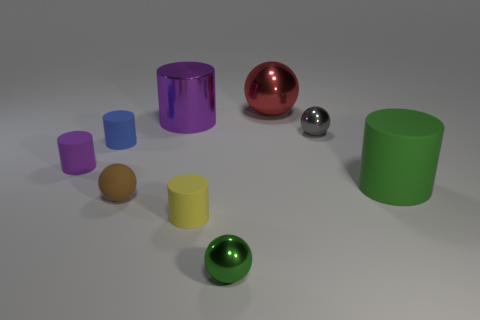Subtract all small matte spheres. How many spheres are left? 3 Subtract all blue cylinders. How many cylinders are left? 4 Add 1 small brown metallic things. How many objects exist? 10 Subtract all cyan spheres. Subtract all cyan cylinders. How many spheres are left? 4 Subtract all spheres. How many objects are left? 5 Add 7 yellow cylinders. How many yellow cylinders exist? 8 Subtract 1 blue cylinders. How many objects are left? 8 Subtract all large red matte blocks. Subtract all tiny brown things. How many objects are left? 8 Add 7 big matte objects. How many big matte objects are left? 8 